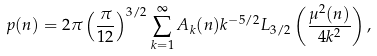Convert formula to latex. <formula><loc_0><loc_0><loc_500><loc_500>p ( n ) = 2 \pi \left ( \frac { \pi } { 1 2 } \right ) ^ { 3 / 2 } \sum _ { k = 1 } ^ { \infty } A _ { k } ( n ) k ^ { - 5 / 2 } L _ { 3 / 2 } \left ( \frac { \mu ^ { 2 } ( n ) } { 4 k ^ { 2 } } \right ) ,</formula> 